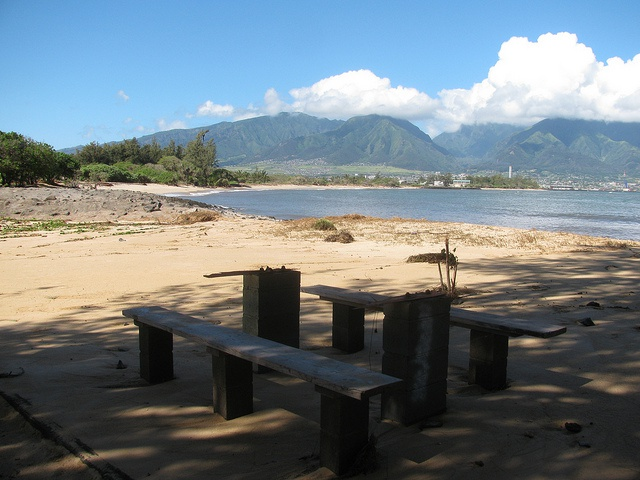Describe the objects in this image and their specific colors. I can see a bench in gray, black, and darkblue tones in this image. 